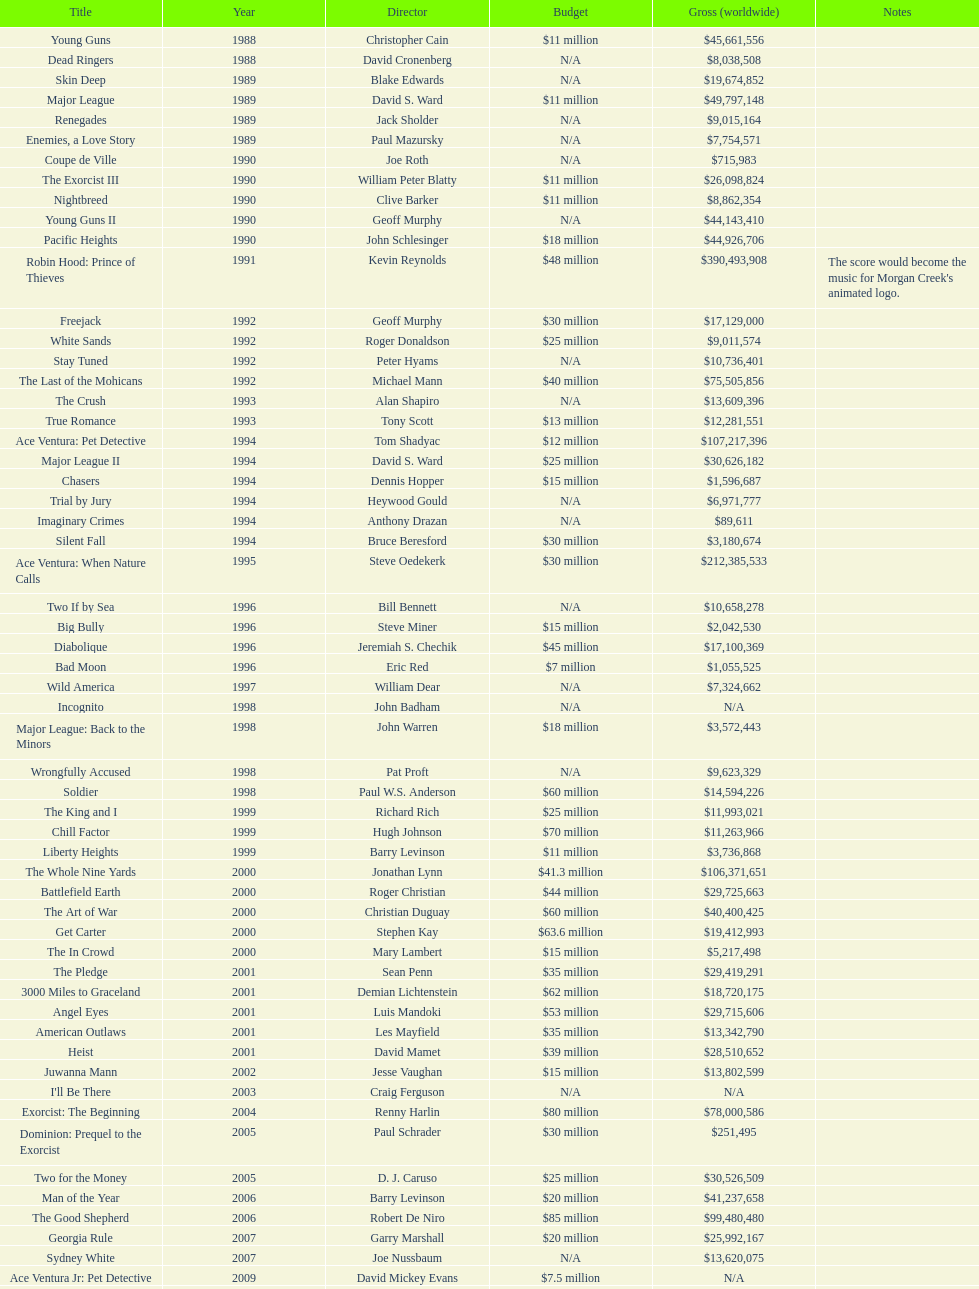Can you give me this table as a dict? {'header': ['Title', 'Year', 'Director', 'Budget', 'Gross (worldwide)', 'Notes'], 'rows': [['Young Guns', '1988', 'Christopher Cain', '$11 million', '$45,661,556', ''], ['Dead Ringers', '1988', 'David Cronenberg', 'N/A', '$8,038,508', ''], ['Skin Deep', '1989', 'Blake Edwards', 'N/A', '$19,674,852', ''], ['Major League', '1989', 'David S. Ward', '$11 million', '$49,797,148', ''], ['Renegades', '1989', 'Jack Sholder', 'N/A', '$9,015,164', ''], ['Enemies, a Love Story', '1989', 'Paul Mazursky', 'N/A', '$7,754,571', ''], ['Coupe de Ville', '1990', 'Joe Roth', 'N/A', '$715,983', ''], ['The Exorcist III', '1990', 'William Peter Blatty', '$11 million', '$26,098,824', ''], ['Nightbreed', '1990', 'Clive Barker', '$11 million', '$8,862,354', ''], ['Young Guns II', '1990', 'Geoff Murphy', 'N/A', '$44,143,410', ''], ['Pacific Heights', '1990', 'John Schlesinger', '$18 million', '$44,926,706', ''], ['Robin Hood: Prince of Thieves', '1991', 'Kevin Reynolds', '$48 million', '$390,493,908', "The score would become the music for Morgan Creek's animated logo."], ['Freejack', '1992', 'Geoff Murphy', '$30 million', '$17,129,000', ''], ['White Sands', '1992', 'Roger Donaldson', '$25 million', '$9,011,574', ''], ['Stay Tuned', '1992', 'Peter Hyams', 'N/A', '$10,736,401', ''], ['The Last of the Mohicans', '1992', 'Michael Mann', '$40 million', '$75,505,856', ''], ['The Crush', '1993', 'Alan Shapiro', 'N/A', '$13,609,396', ''], ['True Romance', '1993', 'Tony Scott', '$13 million', '$12,281,551', ''], ['Ace Ventura: Pet Detective', '1994', 'Tom Shadyac', '$12 million', '$107,217,396', ''], ['Major League II', '1994', 'David S. Ward', '$25 million', '$30,626,182', ''], ['Chasers', '1994', 'Dennis Hopper', '$15 million', '$1,596,687', ''], ['Trial by Jury', '1994', 'Heywood Gould', 'N/A', '$6,971,777', ''], ['Imaginary Crimes', '1994', 'Anthony Drazan', 'N/A', '$89,611', ''], ['Silent Fall', '1994', 'Bruce Beresford', '$30 million', '$3,180,674', ''], ['Ace Ventura: When Nature Calls', '1995', 'Steve Oedekerk', '$30 million', '$212,385,533', ''], ['Two If by Sea', '1996', 'Bill Bennett', 'N/A', '$10,658,278', ''], ['Big Bully', '1996', 'Steve Miner', '$15 million', '$2,042,530', ''], ['Diabolique', '1996', 'Jeremiah S. Chechik', '$45 million', '$17,100,369', ''], ['Bad Moon', '1996', 'Eric Red', '$7 million', '$1,055,525', ''], ['Wild America', '1997', 'William Dear', 'N/A', '$7,324,662', ''], ['Incognito', '1998', 'John Badham', 'N/A', 'N/A', ''], ['Major League: Back to the Minors', '1998', 'John Warren', '$18 million', '$3,572,443', ''], ['Wrongfully Accused', '1998', 'Pat Proft', 'N/A', '$9,623,329', ''], ['Soldier', '1998', 'Paul W.S. Anderson', '$60 million', '$14,594,226', ''], ['The King and I', '1999', 'Richard Rich', '$25 million', '$11,993,021', ''], ['Chill Factor', '1999', 'Hugh Johnson', '$70 million', '$11,263,966', ''], ['Liberty Heights', '1999', 'Barry Levinson', '$11 million', '$3,736,868', ''], ['The Whole Nine Yards', '2000', 'Jonathan Lynn', '$41.3 million', '$106,371,651', ''], ['Battlefield Earth', '2000', 'Roger Christian', '$44 million', '$29,725,663', ''], ['The Art of War', '2000', 'Christian Duguay', '$60 million', '$40,400,425', ''], ['Get Carter', '2000', 'Stephen Kay', '$63.6 million', '$19,412,993', ''], ['The In Crowd', '2000', 'Mary Lambert', '$15 million', '$5,217,498', ''], ['The Pledge', '2001', 'Sean Penn', '$35 million', '$29,419,291', ''], ['3000 Miles to Graceland', '2001', 'Demian Lichtenstein', '$62 million', '$18,720,175', ''], ['Angel Eyes', '2001', 'Luis Mandoki', '$53 million', '$29,715,606', ''], ['American Outlaws', '2001', 'Les Mayfield', '$35 million', '$13,342,790', ''], ['Heist', '2001', 'David Mamet', '$39 million', '$28,510,652', ''], ['Juwanna Mann', '2002', 'Jesse Vaughan', '$15 million', '$13,802,599', ''], ["I'll Be There", '2003', 'Craig Ferguson', 'N/A', 'N/A', ''], ['Exorcist: The Beginning', '2004', 'Renny Harlin', '$80 million', '$78,000,586', ''], ['Dominion: Prequel to the Exorcist', '2005', 'Paul Schrader', '$30 million', '$251,495', ''], ['Two for the Money', '2005', 'D. J. Caruso', '$25 million', '$30,526,509', ''], ['Man of the Year', '2006', 'Barry Levinson', '$20 million', '$41,237,658', ''], ['The Good Shepherd', '2006', 'Robert De Niro', '$85 million', '$99,480,480', ''], ['Georgia Rule', '2007', 'Garry Marshall', '$20 million', '$25,992,167', ''], ['Sydney White', '2007', 'Joe Nussbaum', 'N/A', '$13,620,075', ''], ['Ace Ventura Jr: Pet Detective', '2009', 'David Mickey Evans', '$7.5 million', 'N/A', ''], ['Dream House', '2011', 'Jim Sheridan', '$50 million', '$38,502,340', ''], ['The Thing', '2011', 'Matthijs van Heijningen Jr.', '$38 million', '$27,428,670', ''], ['Tupac', '2014', 'Antoine Fuqua', '$45 million', '', '']]} How many movies were produced in the year 1990? 5. 